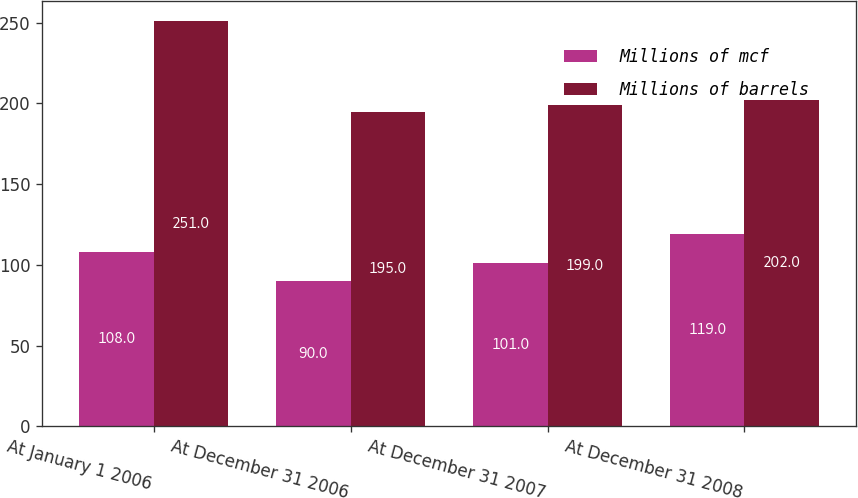Convert chart to OTSL. <chart><loc_0><loc_0><loc_500><loc_500><stacked_bar_chart><ecel><fcel>At January 1 2006<fcel>At December 31 2006<fcel>At December 31 2007<fcel>At December 31 2008<nl><fcel>Millions of mcf<fcel>108<fcel>90<fcel>101<fcel>119<nl><fcel>Millions of barrels<fcel>251<fcel>195<fcel>199<fcel>202<nl></chart> 